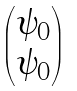<formula> <loc_0><loc_0><loc_500><loc_500>\begin{pmatrix} \psi _ { 0 } \\ \psi _ { 0 } \end{pmatrix}</formula> 